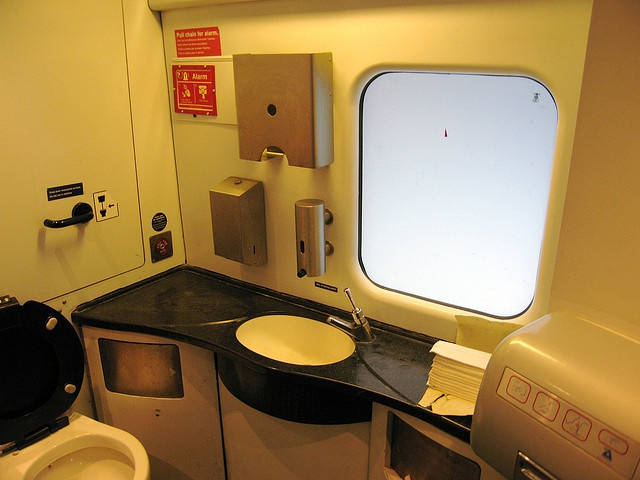Describe the objects in this image and their specific colors. I can see toilet in olive, black, and orange tones, sink in olive, orange, gold, and black tones, and sink in olive, orange, gold, and black tones in this image. 